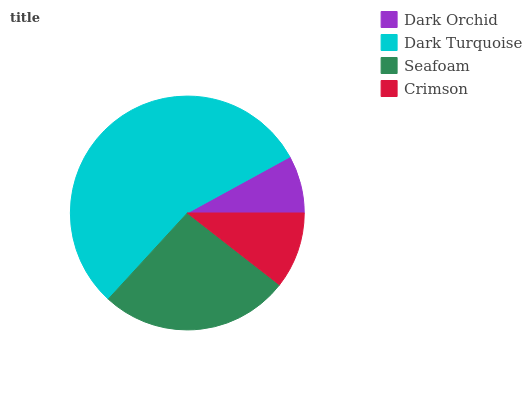Is Dark Orchid the minimum?
Answer yes or no. Yes. Is Dark Turquoise the maximum?
Answer yes or no. Yes. Is Seafoam the minimum?
Answer yes or no. No. Is Seafoam the maximum?
Answer yes or no. No. Is Dark Turquoise greater than Seafoam?
Answer yes or no. Yes. Is Seafoam less than Dark Turquoise?
Answer yes or no. Yes. Is Seafoam greater than Dark Turquoise?
Answer yes or no. No. Is Dark Turquoise less than Seafoam?
Answer yes or no. No. Is Seafoam the high median?
Answer yes or no. Yes. Is Crimson the low median?
Answer yes or no. Yes. Is Crimson the high median?
Answer yes or no. No. Is Dark Orchid the low median?
Answer yes or no. No. 